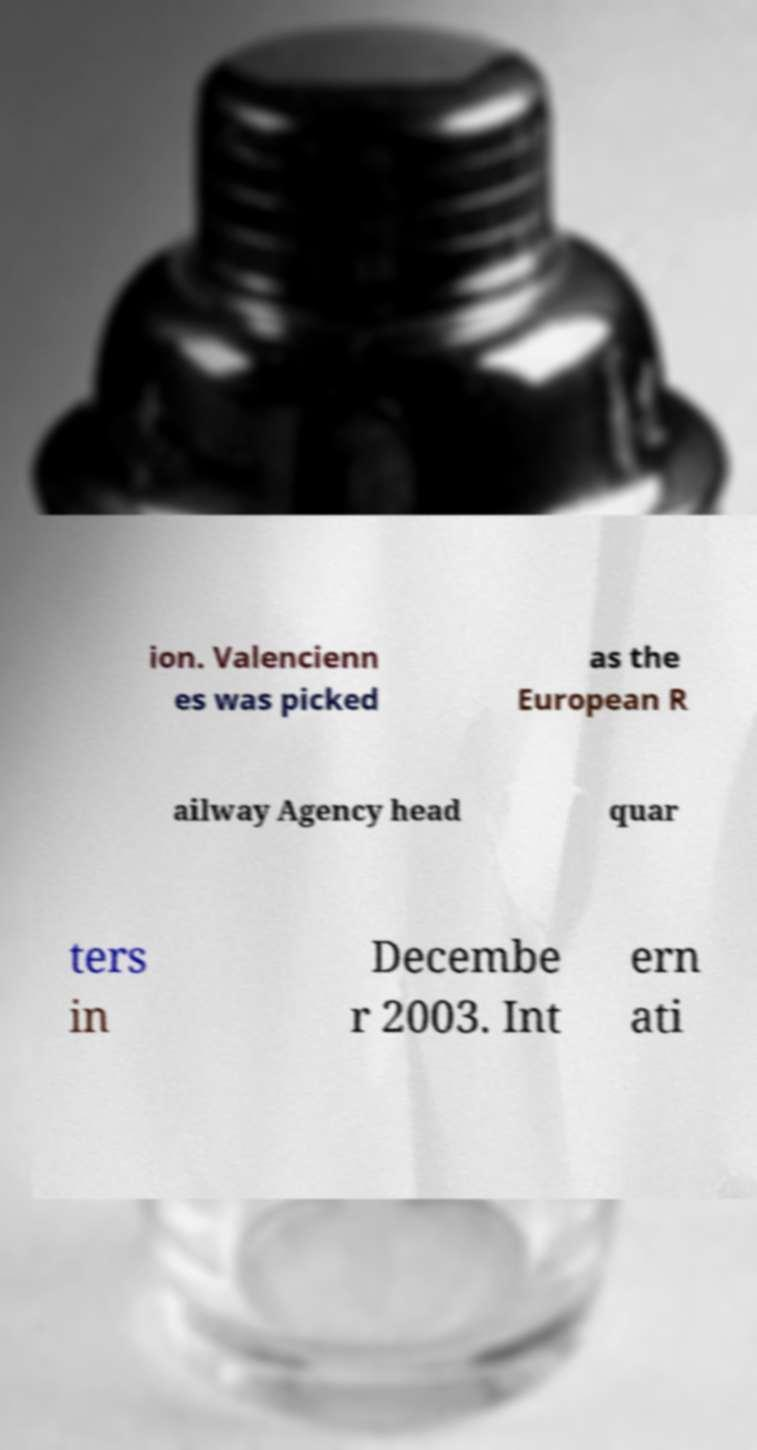Could you extract and type out the text from this image? ion. Valencienn es was picked as the European R ailway Agency head quar ters in Decembe r 2003. Int ern ati 